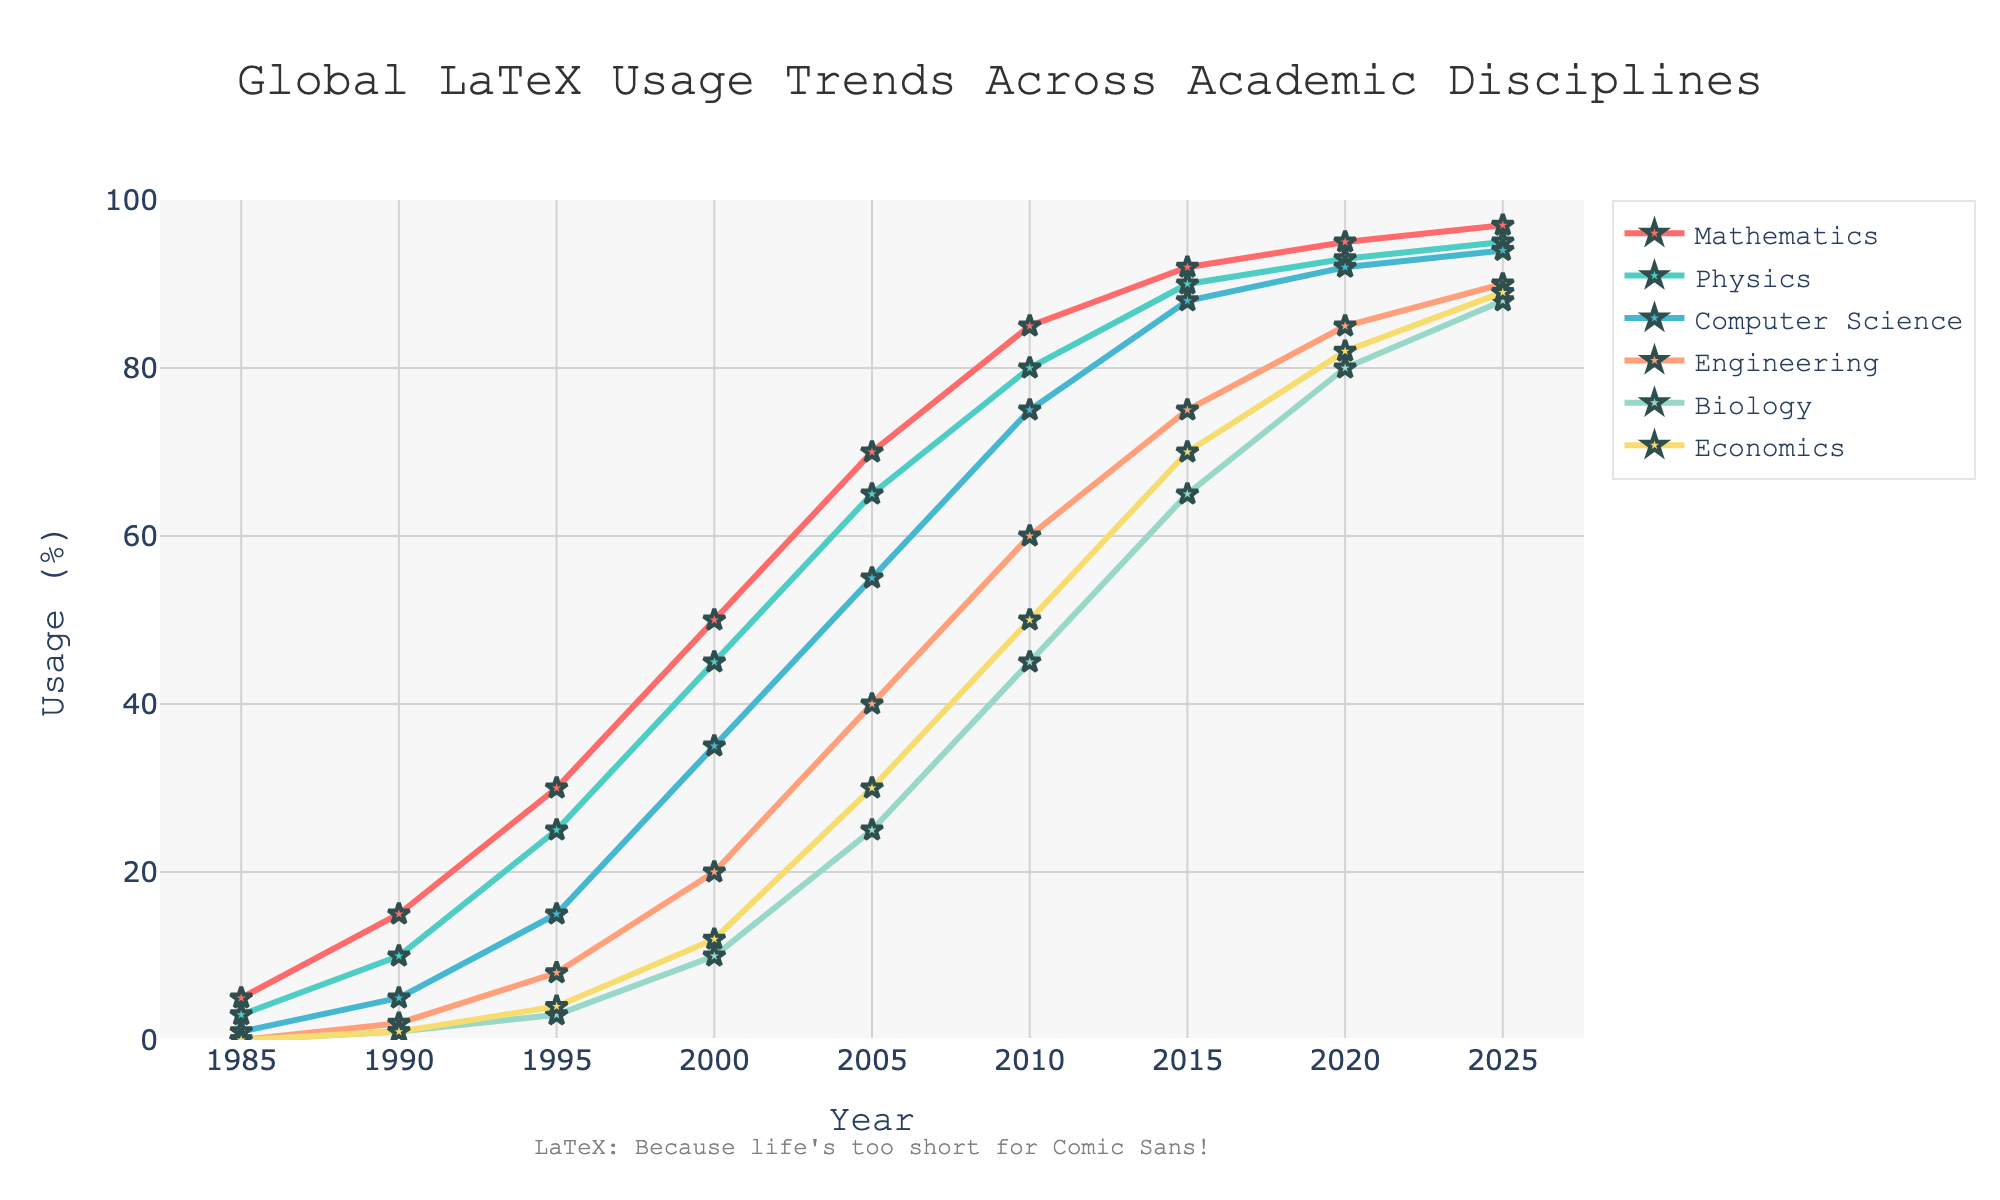What's the usage trend of LaTeX in Mathematics between 1985 and 2025? From the figure, the usage trend in Mathematics increases steadily from 5% in 1985 to 97% in 2025. The trend line shows a consistent upward slope.
Answer: Steadily increasing Which academic discipline had the highest LaTeX usage in 2015? By referring to the plotted lines and markers at the year 2015, Mathematics has the highest usage at 92%.
Answer: Mathematics Compare the LaTeX usage in Biology and Economics in 2020. Which one had a higher percentage? In 2020, the plotted line for Biology reaches 80%, while the line for Economics reaches 82%. Thus, Economics has a higher percentage than Biology.
Answer: Economics What is the difference in LaTeX usage between Engineering and Physics in 2000? The usage percentages in 2000 are 20% for Engineering and 45% for Physics. Therefore, the difference is 45% - 20% = 25%.
Answer: 25% In which year did Computer Science reach a 50% usage rate? Observing the plotted lines, Computer Science reaches 50% usage between the years 2000 and 2005. However, it is closest to 50% around 2005.
Answer: 2005 What is the average LaTeX usage across all disciplines in 1995? The usage percentages for all disciplines in 1995 are Mathematics (30%), Physics (25%), Computer Science (15%), Engineering (8%), Biology (3%), and Economics (4%). The average usage is (30 + 25 + 15 + 8 + 3 + 4) / 6 = 85 / 6 ≈ 14.17%.
Answer: 14.17% Which discipline saw the largest growth in LaTeX usage between 1990 and 2000? Between 1990 and 2000, the growth in LaTeX usage is Mathematics (50% - 15% = 35%), Physics (45% - 10% = 35%), Computer Science (35% - 5% = 30%), Engineering (20% - 2% = 18%), Biology (10% - 1% = 9%), and Economics (12% - 1% = 11%). Mathematics and Physics saw the largest growth of 35%.
Answer: Mathematics and Physics How many disciplines had a LaTeX usage of at least 85% in 2025? In 2025, the usage percentages that are at least 85% are Mathematics (97%), Physics (95%), Computer Science (94%), Engineering (90%), Biology (88%), and Economics (89%). Hence, all six disciplines meet the criterion.
Answer: Six By 2025, what is the percentage increase in LaTeX usage for Biology since 1985? The LaTeX usage in Biology in 2025 is 88%, and in 1985 it is 0%. The percentage increase is (88% - 0%) / 0% * 100. Since the initial usage is 0, the percentage increase is effectively 88%.
Answer: 88% Which discipline exhibits a consistent upward trend without any dips? Observing the plotted lines, all disciplines exhibit a consistent upward trend without dips in their LaTeX usage.
Answer: All 